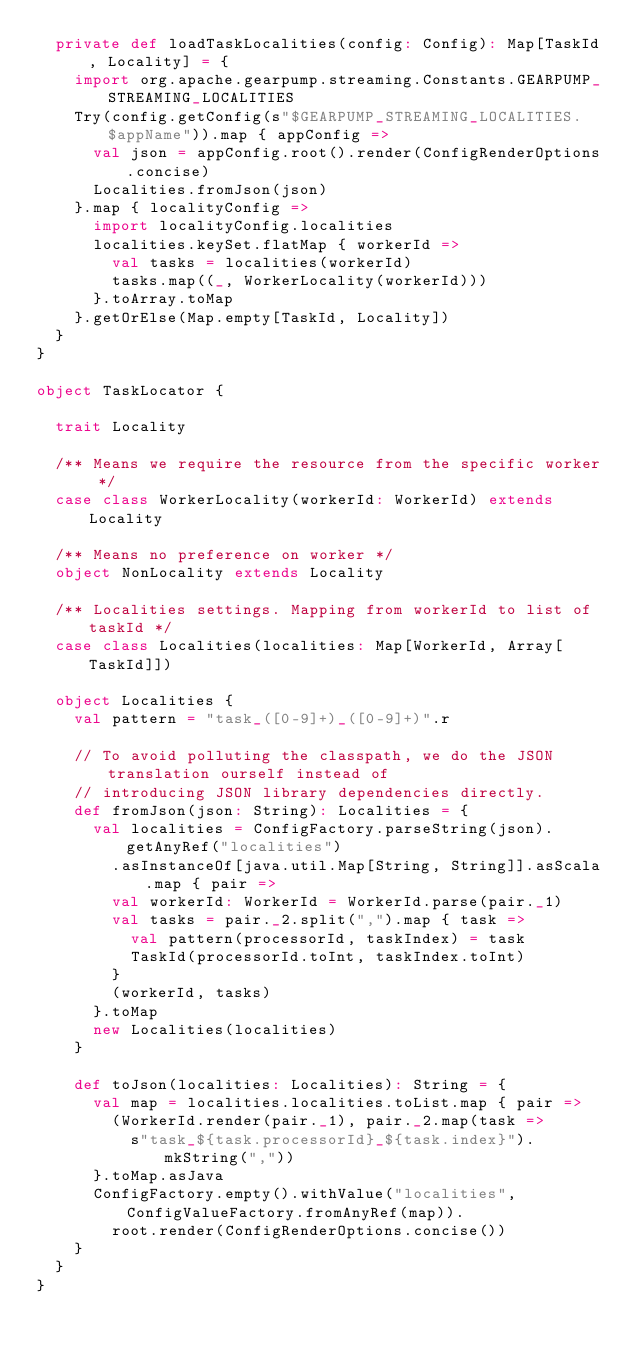Convert code to text. <code><loc_0><loc_0><loc_500><loc_500><_Scala_>  private def loadTaskLocalities(config: Config): Map[TaskId, Locality] = {
    import org.apache.gearpump.streaming.Constants.GEARPUMP_STREAMING_LOCALITIES
    Try(config.getConfig(s"$GEARPUMP_STREAMING_LOCALITIES.$appName")).map { appConfig =>
      val json = appConfig.root().render(ConfigRenderOptions.concise)
      Localities.fromJson(json)
    }.map { localityConfig =>
      import localityConfig.localities
      localities.keySet.flatMap { workerId =>
        val tasks = localities(workerId)
        tasks.map((_, WorkerLocality(workerId)))
      }.toArray.toMap
    }.getOrElse(Map.empty[TaskId, Locality])
  }
}

object TaskLocator {

  trait Locality

  /** Means we require the resource from the specific worker */
  case class WorkerLocality(workerId: WorkerId) extends Locality

  /** Means no preference on worker */
  object NonLocality extends Locality

  /** Localities settings. Mapping from workerId to list of taskId */
  case class Localities(localities: Map[WorkerId, Array[TaskId]])

  object Localities {
    val pattern = "task_([0-9]+)_([0-9]+)".r

    // To avoid polluting the classpath, we do the JSON translation ourself instead of
    // introducing JSON library dependencies directly.
    def fromJson(json: String): Localities = {
      val localities = ConfigFactory.parseString(json).getAnyRef("localities")
        .asInstanceOf[java.util.Map[String, String]].asScala.map { pair =>
        val workerId: WorkerId = WorkerId.parse(pair._1)
        val tasks = pair._2.split(",").map { task =>
          val pattern(processorId, taskIndex) = task
          TaskId(processorId.toInt, taskIndex.toInt)
        }
        (workerId, tasks)
      }.toMap
      new Localities(localities)
    }

    def toJson(localities: Localities): String = {
      val map = localities.localities.toList.map { pair =>
        (WorkerId.render(pair._1), pair._2.map(task =>
          s"task_${task.processorId}_${task.index}").mkString(","))
      }.toMap.asJava
      ConfigFactory.empty().withValue("localities", ConfigValueFactory.fromAnyRef(map)).
        root.render(ConfigRenderOptions.concise())
    }
  }
}</code> 